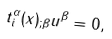Convert formula to latex. <formula><loc_0><loc_0><loc_500><loc_500>t _ { i } ^ { \alpha } ( x ) _ { ; \beta } u ^ { \beta } = 0 ,</formula> 